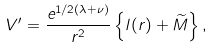Convert formula to latex. <formula><loc_0><loc_0><loc_500><loc_500>V ^ { \prime } = \frac { e ^ { 1 / 2 ( \lambda + \nu ) } } { r ^ { 2 } } \left \{ l ( r ) + \widetilde { M } \right \} ,</formula> 